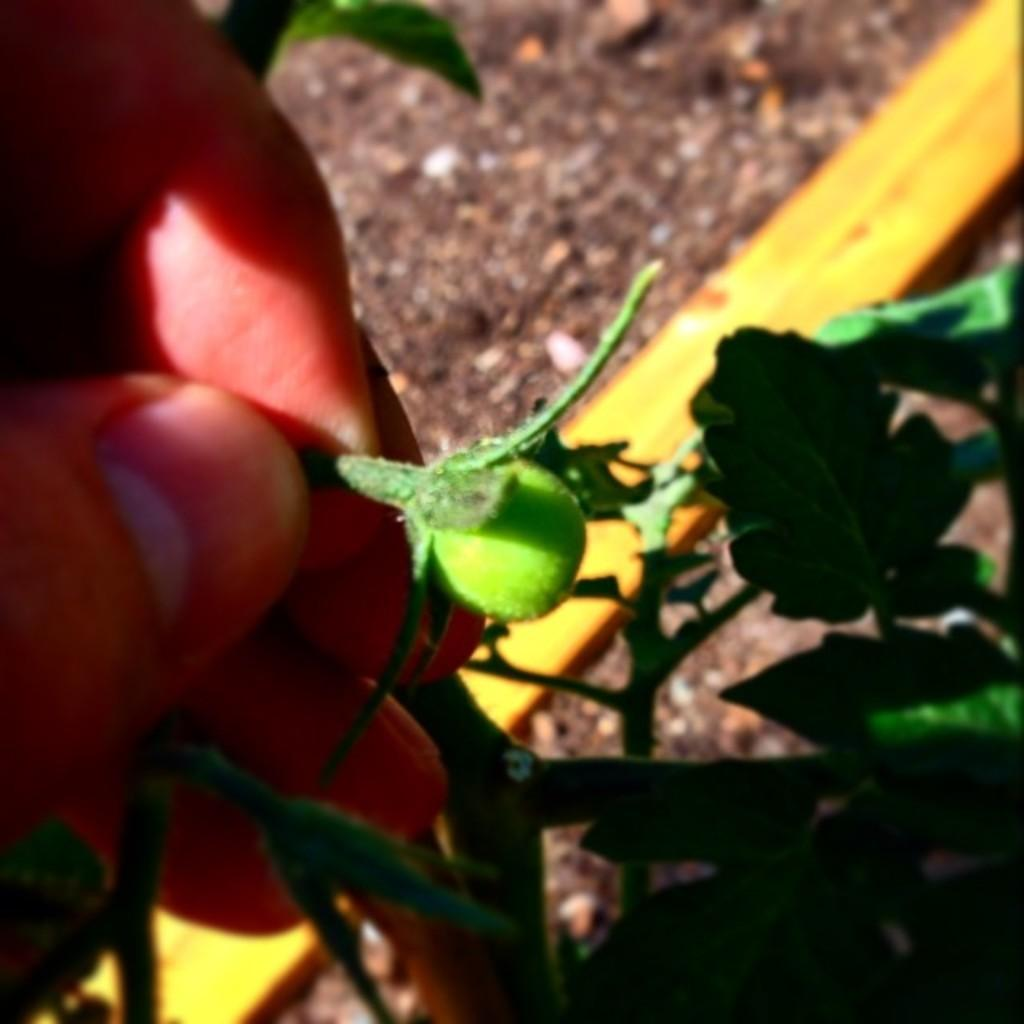What is being held by the human fingers in the image? There are human fingers holding a fruit in the image. What type of food is the fruit from? The fruit is from a plant. What color is the object in the image? There is a yellow color object in the image. Can you describe the background of the image? The background of the image is blurred. What type of writing can be seen on the front of the vessel in the image? There is no vessel present in the image, so there is no writing to be observed on its front. 